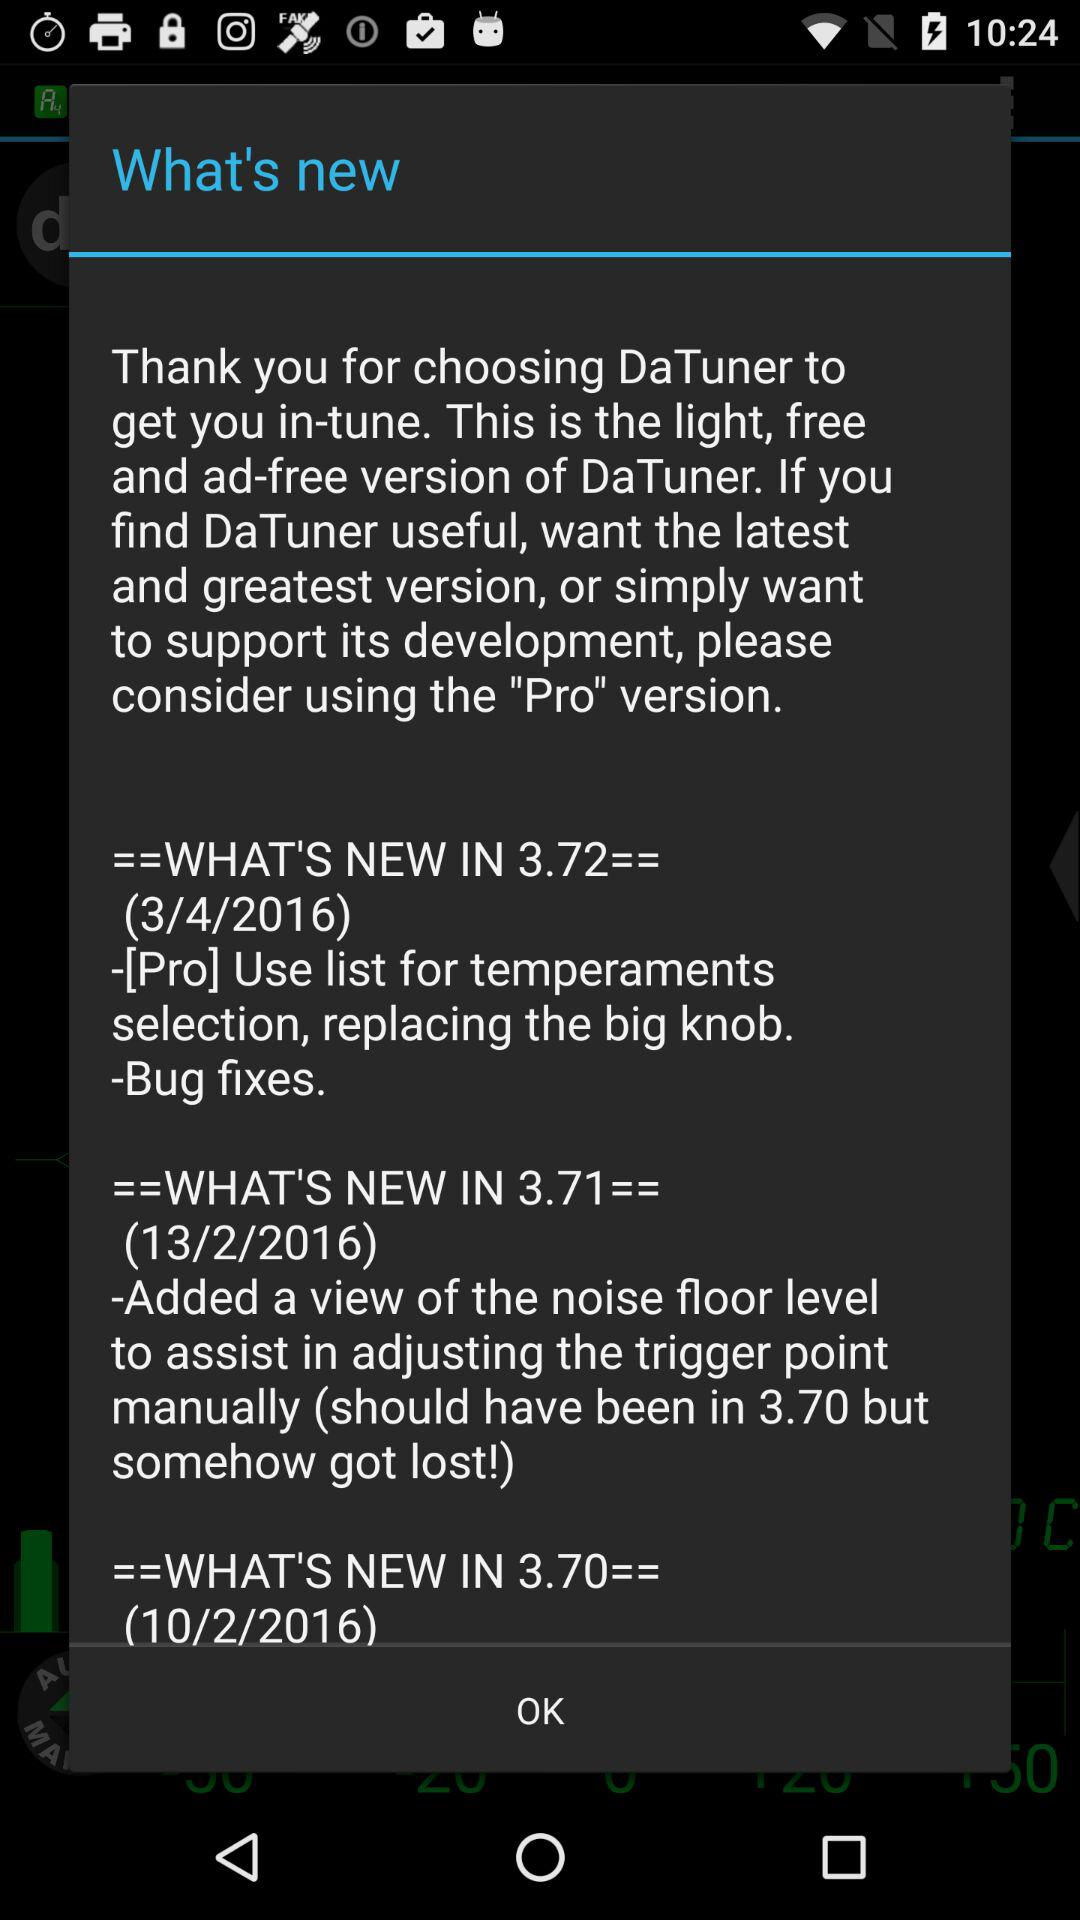How many versions of DaTuner are newer than 3.70?
Answer the question using a single word or phrase. 2 